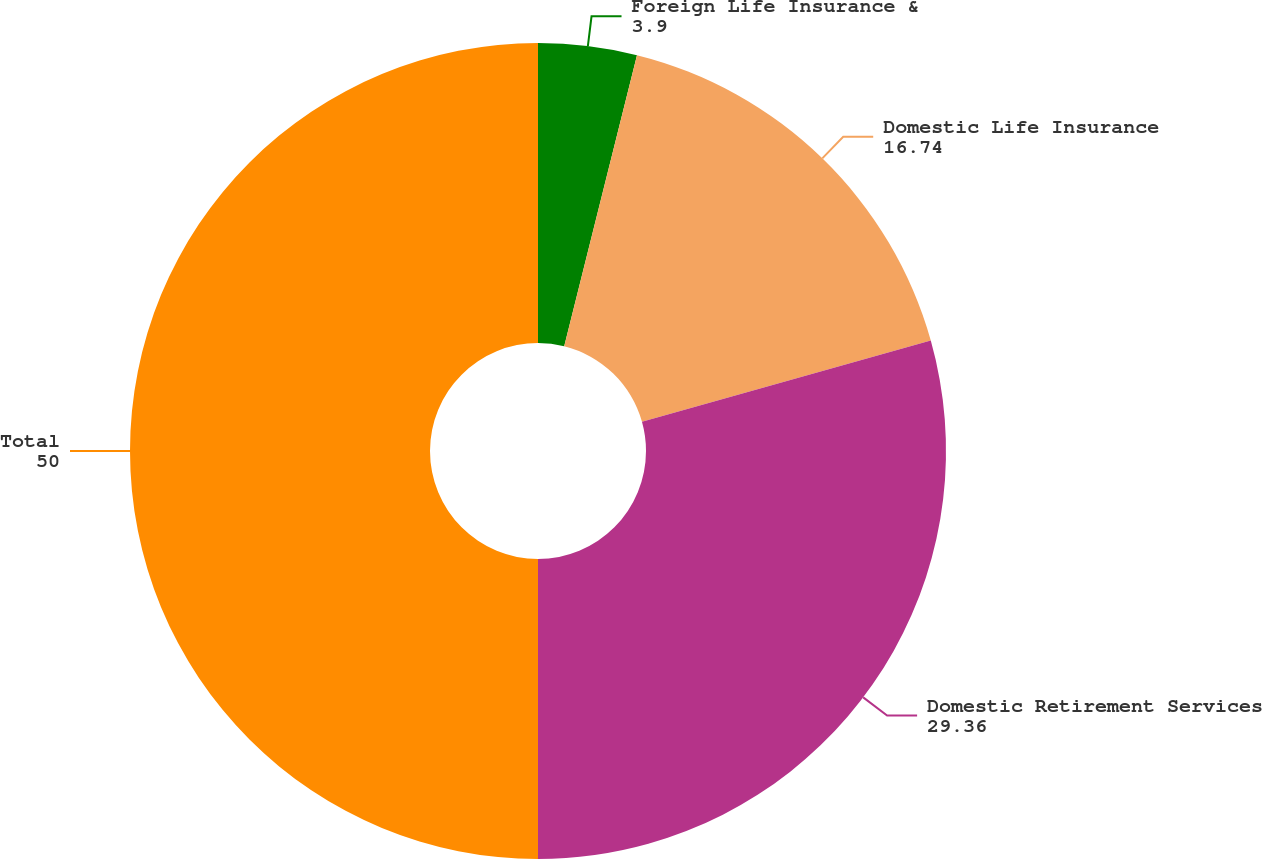Convert chart. <chart><loc_0><loc_0><loc_500><loc_500><pie_chart><fcel>Foreign Life Insurance &<fcel>Domestic Life Insurance<fcel>Domestic Retirement Services<fcel>Total<nl><fcel>3.9%<fcel>16.74%<fcel>29.36%<fcel>50.0%<nl></chart> 